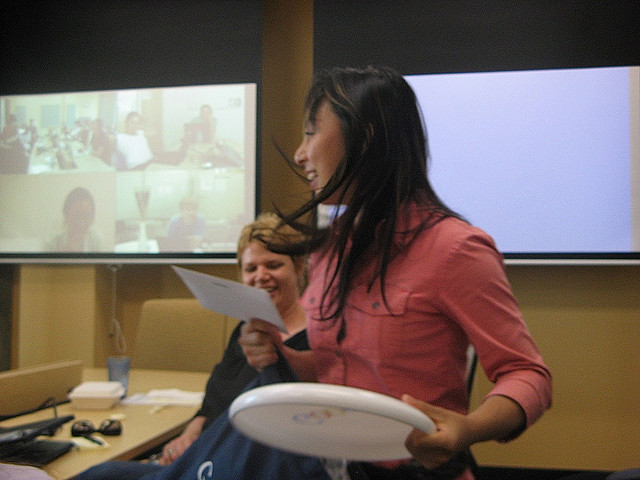<image>What is the theme of the cake? There is no cake in the image. What is the theme of the cake? I don't know the theme of the cake. It is possible that there is no cake in the image. However, it can be a birthday cake. 